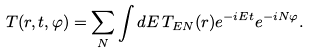<formula> <loc_0><loc_0><loc_500><loc_500>T ( r , t , \varphi ) = \sum _ { N } \int d E \, T _ { E N } ( r ) e ^ { - i E t } e ^ { - i N \varphi } .</formula> 